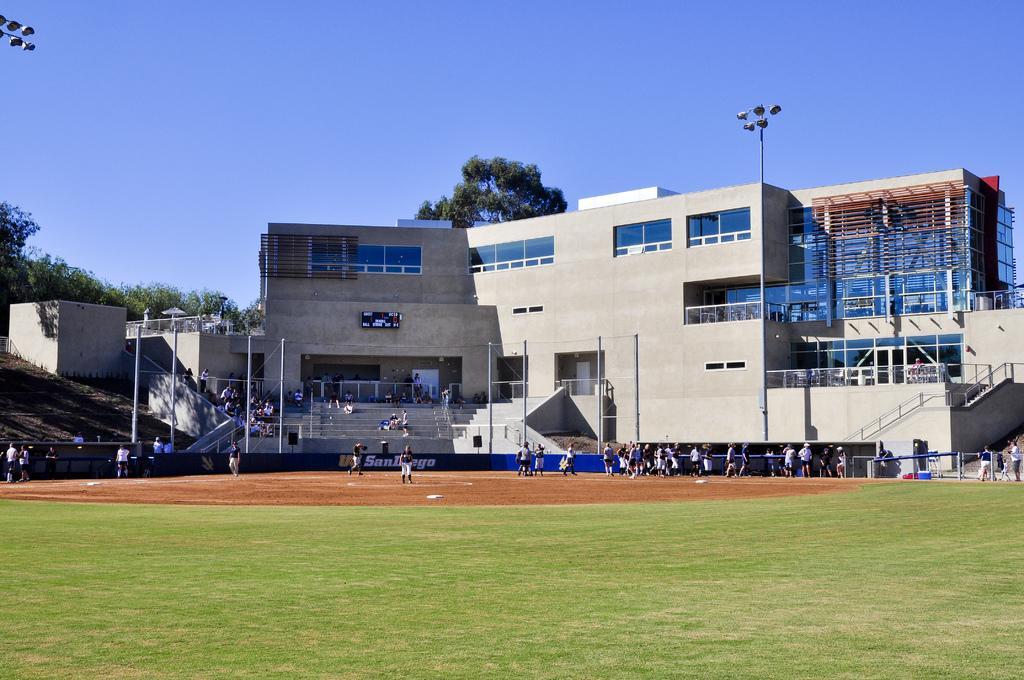In one or two sentences, can you explain what this image depicts? In this image I can see at the bottom there is the grass, in the middle few people are playing the game. In the background there are buildings and trees, there are lights on either side of this image. At the top there is the sky. 